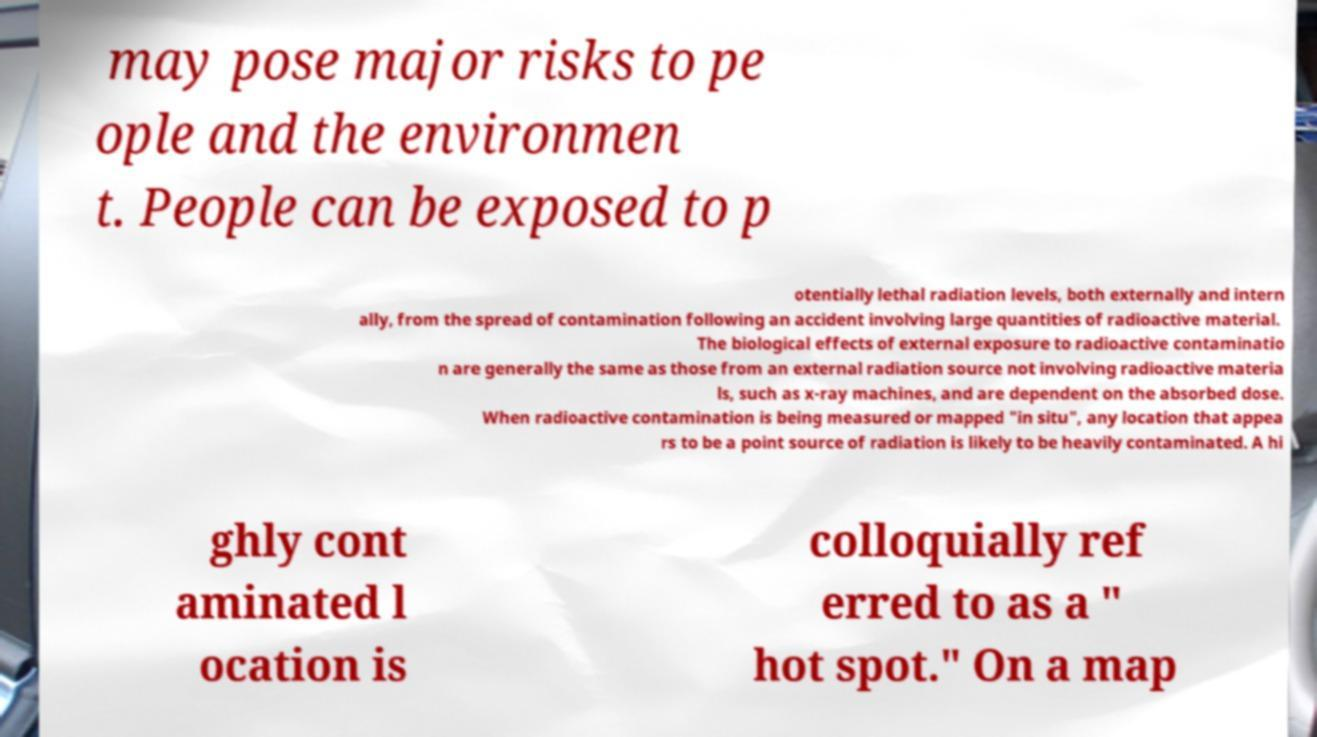There's text embedded in this image that I need extracted. Can you transcribe it verbatim? may pose major risks to pe ople and the environmen t. People can be exposed to p otentially lethal radiation levels, both externally and intern ally, from the spread of contamination following an accident involving large quantities of radioactive material. The biological effects of external exposure to radioactive contaminatio n are generally the same as those from an external radiation source not involving radioactive materia ls, such as x-ray machines, and are dependent on the absorbed dose. When radioactive contamination is being measured or mapped "in situ", any location that appea rs to be a point source of radiation is likely to be heavily contaminated. A hi ghly cont aminated l ocation is colloquially ref erred to as a " hot spot." On a map 